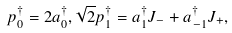<formula> <loc_0><loc_0><loc_500><loc_500>p _ { 0 } ^ { \dagger } = 2 a _ { 0 } ^ { \dagger } , \sqrt { 2 } p _ { 1 } ^ { \dagger } = a _ { 1 } ^ { \dagger } J _ { - } + a _ { - 1 } ^ { \dagger } J _ { + } ,</formula> 